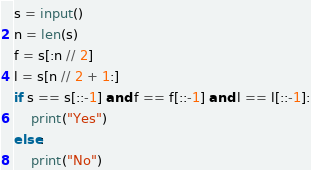Convert code to text. <code><loc_0><loc_0><loc_500><loc_500><_Python_>s = input()
n = len(s)
f = s[:n // 2]
l = s[n // 2 + 1:]
if s == s[::-1] and f == f[::-1] and l == l[::-1]:
    print("Yes")
else:
    print("No")</code> 